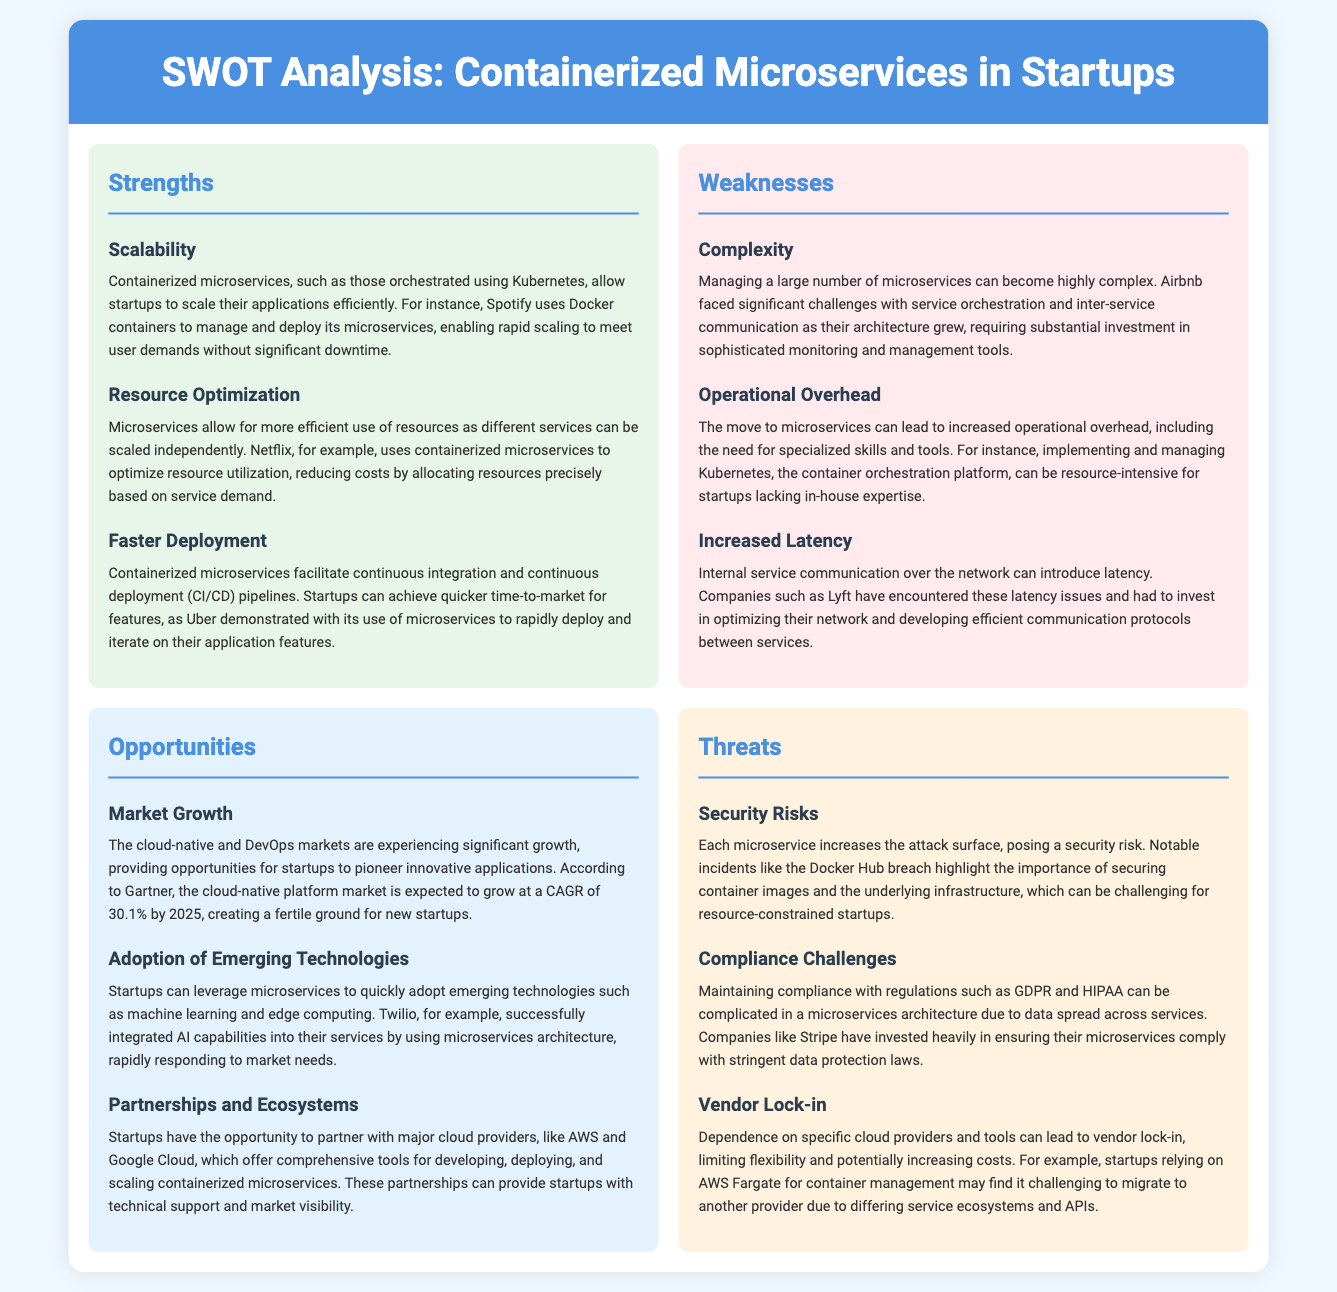What is a key strength of containerized microservices? The document states that scalability is a key strength of containerized microservices, as they allow startups to scale applications efficiently.
Answer: Scalability Which company uses Docker containers to manage its microservices? The document cites Spotify as an example of a company using Docker containers for microservices management.
Answer: Spotify What is one of the weaknesses related to managing microservices? The document highlights complexity as a significant weakness in managing a large number of microservices.
Answer: Complexity What is the expected CAGR for the cloud-native platform market by 2025? According to the document, the cloud-native platform market is expected to grow at a CAGR of 30.1% by 2025.
Answer: 30.1% What type of risks does each microservice increase according to the document? The document refers to security risks as a threat associated with each additional microservice.
Answer: Security risks What challenge did Airbnb face as their architecture grew? The document indicates that Airbnb faced challenges with service orchestration and inter-service communication.
Answer: Service orchestration and inter-service communication Which company invested heavily in compliance assurance for its microservices? The document mentions Stripe as a company that invested significantly in ensuring compliance for its microservices.
Answer: Stripe What opportunity does the document mention for startups in relation to cloud providers? The document states that startups have the opportunity to partner with major cloud providers to gain technical support and market visibility.
Answer: Partnerships with major cloud providers What is an operational overhead concern with microservices? Increased operational overhead is highlighted as a concern when moving to microservices, including the need for specialized skills.
Answer: Increased operational overhead 